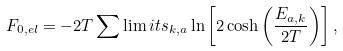<formula> <loc_0><loc_0><loc_500><loc_500>F _ { 0 , e l } = - 2 T \sum \lim i t s _ { k , a } \ln \left [ 2 \cosh \left ( \frac { E _ { a , k } } { 2 T } \right ) \right ] ,</formula> 